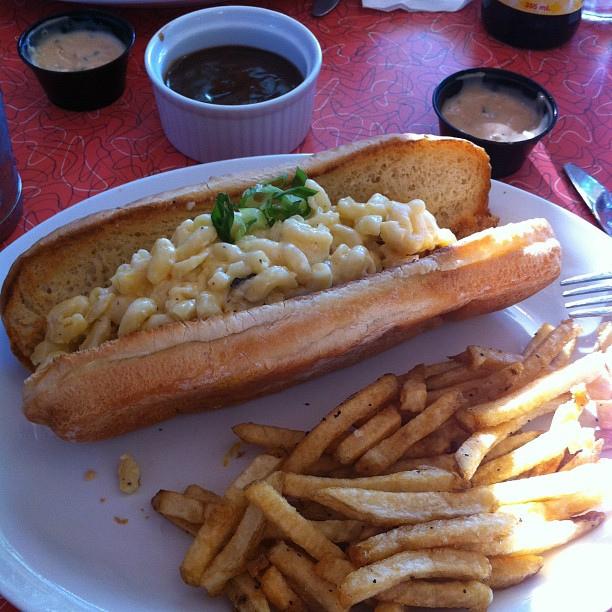What is on the roll?
Write a very short answer. Macaroni. Do you need a fork to eat this?
Be succinct. No. How many sauces are there?
Keep it brief. 3. 